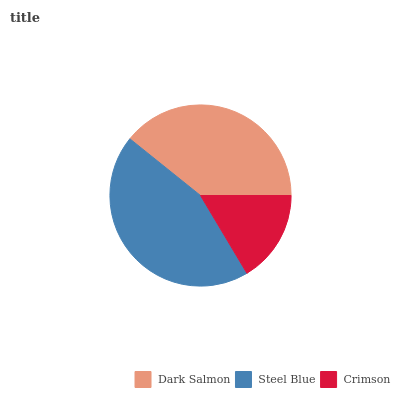Is Crimson the minimum?
Answer yes or no. Yes. Is Steel Blue the maximum?
Answer yes or no. Yes. Is Steel Blue the minimum?
Answer yes or no. No. Is Crimson the maximum?
Answer yes or no. No. Is Steel Blue greater than Crimson?
Answer yes or no. Yes. Is Crimson less than Steel Blue?
Answer yes or no. Yes. Is Crimson greater than Steel Blue?
Answer yes or no. No. Is Steel Blue less than Crimson?
Answer yes or no. No. Is Dark Salmon the high median?
Answer yes or no. Yes. Is Dark Salmon the low median?
Answer yes or no. Yes. Is Crimson the high median?
Answer yes or no. No. Is Crimson the low median?
Answer yes or no. No. 